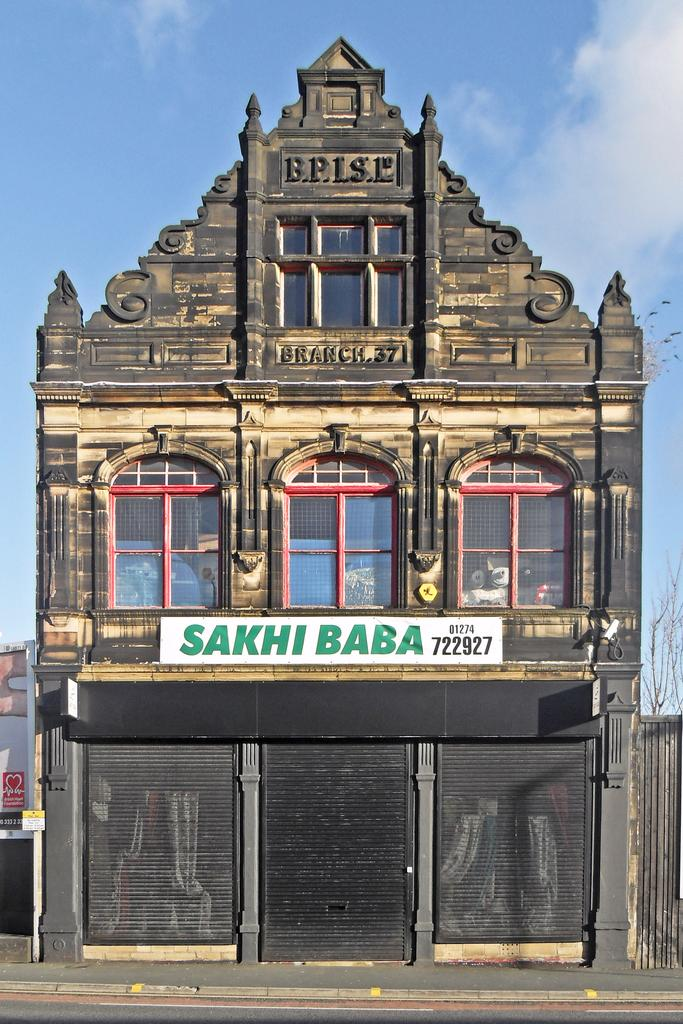What type of structures can be seen in the image? There are buildings in the image. What architectural features are present on the buildings? There are windows and shutters visible on the buildings. What is the object with writing on it in the image? There is a board in the image. What type of barrier is present in the image? There is a fence in the image. What type of vegetation is present in the image? There are trees in the image. What part of the natural environment is visible in the image? The sky is visible in the image. Based on the presence of the sky and the absence of artificial lighting, when might the image have been taken? The image is likely taken during the day. What grade does the star on the board represent in the image? There is no star present on the board in the image, and therefore no grade can be associated with it. How does the bit of wood affect the buildings in the image? There is no bit of wood mentioned in the image, so its impact on the buildings cannot be determined. 